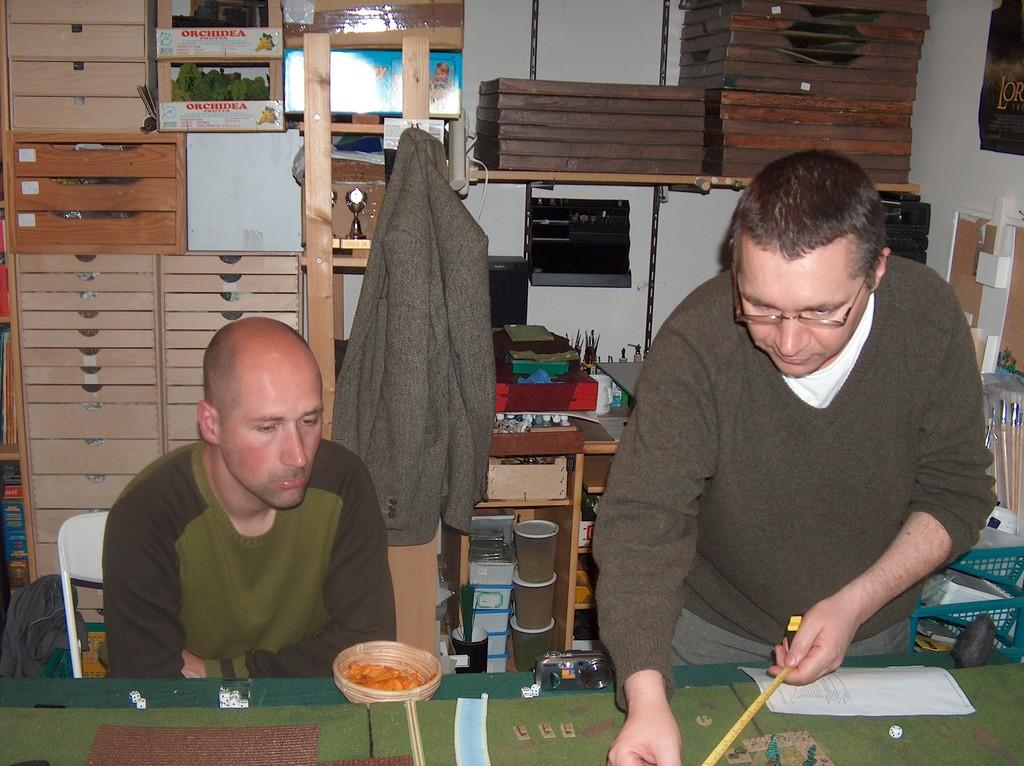How many men are present in the image? There are two men in the image. What are the positions of the men in the image? One man is standing, and the other man is sitting on a chair. What objects can be seen in the background of the image? There is a jacket and glasses in the background of the image. What type of grip does the man have on the oatmeal in the image? There is no oatmeal present in the image, and therefore no grip can be observed. What type of destruction is happening in the image? There is no destruction present in the image; it features two men in different positions with a jacket and glasses in the background. 